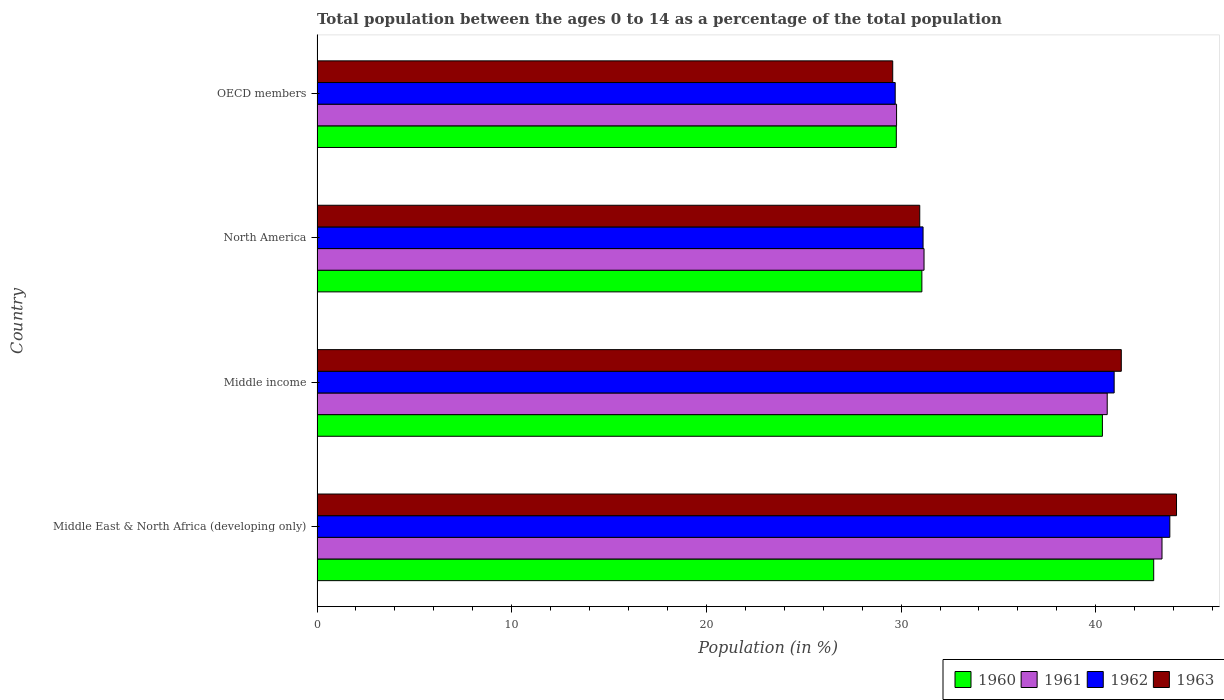How many different coloured bars are there?
Keep it short and to the point. 4. Are the number of bars per tick equal to the number of legend labels?
Ensure brevity in your answer.  Yes. Are the number of bars on each tick of the Y-axis equal?
Keep it short and to the point. Yes. What is the percentage of the population ages 0 to 14 in 1960 in North America?
Keep it short and to the point. 31.07. Across all countries, what is the maximum percentage of the population ages 0 to 14 in 1963?
Your response must be concise. 44.15. Across all countries, what is the minimum percentage of the population ages 0 to 14 in 1962?
Offer a terse response. 29.7. In which country was the percentage of the population ages 0 to 14 in 1960 maximum?
Make the answer very short. Middle East & North Africa (developing only). In which country was the percentage of the population ages 0 to 14 in 1962 minimum?
Provide a short and direct response. OECD members. What is the total percentage of the population ages 0 to 14 in 1962 in the graph?
Provide a short and direct response. 145.57. What is the difference between the percentage of the population ages 0 to 14 in 1960 in Middle income and that in OECD members?
Offer a terse response. 10.59. What is the difference between the percentage of the population ages 0 to 14 in 1960 in Middle income and the percentage of the population ages 0 to 14 in 1961 in Middle East & North Africa (developing only)?
Ensure brevity in your answer.  -3.06. What is the average percentage of the population ages 0 to 14 in 1963 per country?
Keep it short and to the point. 36.5. What is the difference between the percentage of the population ages 0 to 14 in 1961 and percentage of the population ages 0 to 14 in 1960 in OECD members?
Keep it short and to the point. 0.01. What is the ratio of the percentage of the population ages 0 to 14 in 1961 in Middle income to that in OECD members?
Your response must be concise. 1.36. Is the percentage of the population ages 0 to 14 in 1963 in Middle East & North Africa (developing only) less than that in North America?
Provide a short and direct response. No. What is the difference between the highest and the second highest percentage of the population ages 0 to 14 in 1963?
Ensure brevity in your answer.  2.84. What is the difference between the highest and the lowest percentage of the population ages 0 to 14 in 1962?
Provide a short and direct response. 14.11. In how many countries, is the percentage of the population ages 0 to 14 in 1963 greater than the average percentage of the population ages 0 to 14 in 1963 taken over all countries?
Offer a very short reply. 2. Is the sum of the percentage of the population ages 0 to 14 in 1961 in Middle income and North America greater than the maximum percentage of the population ages 0 to 14 in 1960 across all countries?
Keep it short and to the point. Yes. Is it the case that in every country, the sum of the percentage of the population ages 0 to 14 in 1960 and percentage of the population ages 0 to 14 in 1961 is greater than the sum of percentage of the population ages 0 to 14 in 1962 and percentage of the population ages 0 to 14 in 1963?
Provide a short and direct response. No. Is it the case that in every country, the sum of the percentage of the population ages 0 to 14 in 1963 and percentage of the population ages 0 to 14 in 1961 is greater than the percentage of the population ages 0 to 14 in 1962?
Ensure brevity in your answer.  Yes. How many bars are there?
Keep it short and to the point. 16. What is the difference between two consecutive major ticks on the X-axis?
Provide a succinct answer. 10. Does the graph contain any zero values?
Ensure brevity in your answer.  No. Does the graph contain grids?
Ensure brevity in your answer.  No. How are the legend labels stacked?
Offer a very short reply. Horizontal. What is the title of the graph?
Keep it short and to the point. Total population between the ages 0 to 14 as a percentage of the total population. Does "1975" appear as one of the legend labels in the graph?
Make the answer very short. No. What is the label or title of the Y-axis?
Offer a terse response. Country. What is the Population (in %) in 1960 in Middle East & North Africa (developing only)?
Provide a succinct answer. 42.97. What is the Population (in %) in 1961 in Middle East & North Africa (developing only)?
Make the answer very short. 43.4. What is the Population (in %) of 1962 in Middle East & North Africa (developing only)?
Provide a short and direct response. 43.8. What is the Population (in %) in 1963 in Middle East & North Africa (developing only)?
Make the answer very short. 44.15. What is the Population (in %) in 1960 in Middle income?
Keep it short and to the point. 40.34. What is the Population (in %) in 1961 in Middle income?
Keep it short and to the point. 40.59. What is the Population (in %) in 1962 in Middle income?
Your answer should be compact. 40.94. What is the Population (in %) of 1963 in Middle income?
Offer a very short reply. 41.31. What is the Population (in %) of 1960 in North America?
Give a very brief answer. 31.07. What is the Population (in %) of 1961 in North America?
Keep it short and to the point. 31.18. What is the Population (in %) in 1962 in North America?
Provide a succinct answer. 31.13. What is the Population (in %) of 1963 in North America?
Provide a succinct answer. 30.96. What is the Population (in %) in 1960 in OECD members?
Offer a terse response. 29.75. What is the Population (in %) in 1961 in OECD members?
Your response must be concise. 29.77. What is the Population (in %) of 1962 in OECD members?
Ensure brevity in your answer.  29.7. What is the Population (in %) in 1963 in OECD members?
Make the answer very short. 29.57. Across all countries, what is the maximum Population (in %) of 1960?
Offer a very short reply. 42.97. Across all countries, what is the maximum Population (in %) in 1961?
Ensure brevity in your answer.  43.4. Across all countries, what is the maximum Population (in %) of 1962?
Your answer should be compact. 43.8. Across all countries, what is the maximum Population (in %) in 1963?
Make the answer very short. 44.15. Across all countries, what is the minimum Population (in %) in 1960?
Ensure brevity in your answer.  29.75. Across all countries, what is the minimum Population (in %) of 1961?
Keep it short and to the point. 29.77. Across all countries, what is the minimum Population (in %) in 1962?
Give a very brief answer. 29.7. Across all countries, what is the minimum Population (in %) in 1963?
Give a very brief answer. 29.57. What is the total Population (in %) in 1960 in the graph?
Offer a very short reply. 144.14. What is the total Population (in %) of 1961 in the graph?
Provide a succinct answer. 144.93. What is the total Population (in %) of 1962 in the graph?
Offer a very short reply. 145.57. What is the total Population (in %) in 1963 in the graph?
Provide a short and direct response. 145.98. What is the difference between the Population (in %) of 1960 in Middle East & North Africa (developing only) and that in Middle income?
Your answer should be very brief. 2.63. What is the difference between the Population (in %) in 1961 in Middle East & North Africa (developing only) and that in Middle income?
Your response must be concise. 2.81. What is the difference between the Population (in %) of 1962 in Middle East & North Africa (developing only) and that in Middle income?
Offer a very short reply. 2.86. What is the difference between the Population (in %) in 1963 in Middle East & North Africa (developing only) and that in Middle income?
Your answer should be very brief. 2.84. What is the difference between the Population (in %) of 1960 in Middle East & North Africa (developing only) and that in North America?
Your answer should be very brief. 11.91. What is the difference between the Population (in %) of 1961 in Middle East & North Africa (developing only) and that in North America?
Provide a succinct answer. 12.22. What is the difference between the Population (in %) of 1962 in Middle East & North Africa (developing only) and that in North America?
Ensure brevity in your answer.  12.67. What is the difference between the Population (in %) of 1963 in Middle East & North Africa (developing only) and that in North America?
Offer a terse response. 13.19. What is the difference between the Population (in %) of 1960 in Middle East & North Africa (developing only) and that in OECD members?
Offer a terse response. 13.22. What is the difference between the Population (in %) of 1961 in Middle East & North Africa (developing only) and that in OECD members?
Keep it short and to the point. 13.63. What is the difference between the Population (in %) of 1962 in Middle East & North Africa (developing only) and that in OECD members?
Provide a short and direct response. 14.11. What is the difference between the Population (in %) of 1963 in Middle East & North Africa (developing only) and that in OECD members?
Your response must be concise. 14.58. What is the difference between the Population (in %) in 1960 in Middle income and that in North America?
Provide a succinct answer. 9.27. What is the difference between the Population (in %) of 1961 in Middle income and that in North America?
Provide a succinct answer. 9.41. What is the difference between the Population (in %) in 1962 in Middle income and that in North America?
Make the answer very short. 9.82. What is the difference between the Population (in %) in 1963 in Middle income and that in North America?
Make the answer very short. 10.35. What is the difference between the Population (in %) of 1960 in Middle income and that in OECD members?
Offer a terse response. 10.59. What is the difference between the Population (in %) of 1961 in Middle income and that in OECD members?
Make the answer very short. 10.82. What is the difference between the Population (in %) of 1962 in Middle income and that in OECD members?
Offer a terse response. 11.25. What is the difference between the Population (in %) in 1963 in Middle income and that in OECD members?
Your answer should be compact. 11.74. What is the difference between the Population (in %) in 1960 in North America and that in OECD members?
Offer a terse response. 1.31. What is the difference between the Population (in %) of 1961 in North America and that in OECD members?
Your answer should be very brief. 1.41. What is the difference between the Population (in %) in 1962 in North America and that in OECD members?
Keep it short and to the point. 1.43. What is the difference between the Population (in %) of 1963 in North America and that in OECD members?
Offer a terse response. 1.39. What is the difference between the Population (in %) in 1960 in Middle East & North Africa (developing only) and the Population (in %) in 1961 in Middle income?
Provide a short and direct response. 2.39. What is the difference between the Population (in %) of 1960 in Middle East & North Africa (developing only) and the Population (in %) of 1962 in Middle income?
Keep it short and to the point. 2.03. What is the difference between the Population (in %) in 1960 in Middle East & North Africa (developing only) and the Population (in %) in 1963 in Middle income?
Offer a terse response. 1.66. What is the difference between the Population (in %) of 1961 in Middle East & North Africa (developing only) and the Population (in %) of 1962 in Middle income?
Your answer should be compact. 2.46. What is the difference between the Population (in %) of 1961 in Middle East & North Africa (developing only) and the Population (in %) of 1963 in Middle income?
Your answer should be very brief. 2.09. What is the difference between the Population (in %) in 1962 in Middle East & North Africa (developing only) and the Population (in %) in 1963 in Middle income?
Offer a terse response. 2.49. What is the difference between the Population (in %) of 1960 in Middle East & North Africa (developing only) and the Population (in %) of 1961 in North America?
Make the answer very short. 11.8. What is the difference between the Population (in %) of 1960 in Middle East & North Africa (developing only) and the Population (in %) of 1962 in North America?
Provide a short and direct response. 11.85. What is the difference between the Population (in %) of 1960 in Middle East & North Africa (developing only) and the Population (in %) of 1963 in North America?
Provide a short and direct response. 12.02. What is the difference between the Population (in %) of 1961 in Middle East & North Africa (developing only) and the Population (in %) of 1962 in North America?
Your answer should be compact. 12.27. What is the difference between the Population (in %) in 1961 in Middle East & North Africa (developing only) and the Population (in %) in 1963 in North America?
Keep it short and to the point. 12.44. What is the difference between the Population (in %) of 1962 in Middle East & North Africa (developing only) and the Population (in %) of 1963 in North America?
Offer a very short reply. 12.85. What is the difference between the Population (in %) in 1960 in Middle East & North Africa (developing only) and the Population (in %) in 1961 in OECD members?
Your answer should be compact. 13.21. What is the difference between the Population (in %) in 1960 in Middle East & North Africa (developing only) and the Population (in %) in 1962 in OECD members?
Offer a terse response. 13.28. What is the difference between the Population (in %) of 1960 in Middle East & North Africa (developing only) and the Population (in %) of 1963 in OECD members?
Your answer should be compact. 13.41. What is the difference between the Population (in %) in 1961 in Middle East & North Africa (developing only) and the Population (in %) in 1962 in OECD members?
Your response must be concise. 13.7. What is the difference between the Population (in %) in 1961 in Middle East & North Africa (developing only) and the Population (in %) in 1963 in OECD members?
Your answer should be very brief. 13.83. What is the difference between the Population (in %) in 1962 in Middle East & North Africa (developing only) and the Population (in %) in 1963 in OECD members?
Keep it short and to the point. 14.23. What is the difference between the Population (in %) in 1960 in Middle income and the Population (in %) in 1961 in North America?
Offer a terse response. 9.16. What is the difference between the Population (in %) in 1960 in Middle income and the Population (in %) in 1962 in North America?
Offer a terse response. 9.21. What is the difference between the Population (in %) of 1960 in Middle income and the Population (in %) of 1963 in North America?
Ensure brevity in your answer.  9.38. What is the difference between the Population (in %) of 1961 in Middle income and the Population (in %) of 1962 in North America?
Your answer should be compact. 9.46. What is the difference between the Population (in %) of 1961 in Middle income and the Population (in %) of 1963 in North America?
Your answer should be very brief. 9.63. What is the difference between the Population (in %) in 1962 in Middle income and the Population (in %) in 1963 in North America?
Offer a very short reply. 9.99. What is the difference between the Population (in %) of 1960 in Middle income and the Population (in %) of 1961 in OECD members?
Your answer should be compact. 10.57. What is the difference between the Population (in %) of 1960 in Middle income and the Population (in %) of 1962 in OECD members?
Offer a very short reply. 10.64. What is the difference between the Population (in %) of 1960 in Middle income and the Population (in %) of 1963 in OECD members?
Ensure brevity in your answer.  10.77. What is the difference between the Population (in %) of 1961 in Middle income and the Population (in %) of 1962 in OECD members?
Your answer should be compact. 10.89. What is the difference between the Population (in %) in 1961 in Middle income and the Population (in %) in 1963 in OECD members?
Your answer should be very brief. 11.02. What is the difference between the Population (in %) of 1962 in Middle income and the Population (in %) of 1963 in OECD members?
Keep it short and to the point. 11.37. What is the difference between the Population (in %) in 1960 in North America and the Population (in %) in 1961 in OECD members?
Offer a very short reply. 1.3. What is the difference between the Population (in %) in 1960 in North America and the Population (in %) in 1962 in OECD members?
Provide a succinct answer. 1.37. What is the difference between the Population (in %) in 1960 in North America and the Population (in %) in 1963 in OECD members?
Make the answer very short. 1.5. What is the difference between the Population (in %) in 1961 in North America and the Population (in %) in 1962 in OECD members?
Offer a very short reply. 1.48. What is the difference between the Population (in %) of 1961 in North America and the Population (in %) of 1963 in OECD members?
Ensure brevity in your answer.  1.61. What is the difference between the Population (in %) in 1962 in North America and the Population (in %) in 1963 in OECD members?
Make the answer very short. 1.56. What is the average Population (in %) of 1960 per country?
Provide a succinct answer. 36.03. What is the average Population (in %) in 1961 per country?
Make the answer very short. 36.23. What is the average Population (in %) in 1962 per country?
Offer a terse response. 36.39. What is the average Population (in %) of 1963 per country?
Offer a terse response. 36.5. What is the difference between the Population (in %) of 1960 and Population (in %) of 1961 in Middle East & North Africa (developing only)?
Make the answer very short. -0.43. What is the difference between the Population (in %) of 1960 and Population (in %) of 1962 in Middle East & North Africa (developing only)?
Your response must be concise. -0.83. What is the difference between the Population (in %) of 1960 and Population (in %) of 1963 in Middle East & North Africa (developing only)?
Ensure brevity in your answer.  -1.17. What is the difference between the Population (in %) of 1961 and Population (in %) of 1962 in Middle East & North Africa (developing only)?
Offer a very short reply. -0.4. What is the difference between the Population (in %) of 1961 and Population (in %) of 1963 in Middle East & North Africa (developing only)?
Ensure brevity in your answer.  -0.75. What is the difference between the Population (in %) in 1962 and Population (in %) in 1963 in Middle East & North Africa (developing only)?
Give a very brief answer. -0.34. What is the difference between the Population (in %) in 1960 and Population (in %) in 1961 in Middle income?
Offer a very short reply. -0.25. What is the difference between the Population (in %) of 1960 and Population (in %) of 1962 in Middle income?
Provide a short and direct response. -0.6. What is the difference between the Population (in %) of 1960 and Population (in %) of 1963 in Middle income?
Your answer should be compact. -0.97. What is the difference between the Population (in %) of 1961 and Population (in %) of 1962 in Middle income?
Ensure brevity in your answer.  -0.36. What is the difference between the Population (in %) of 1961 and Population (in %) of 1963 in Middle income?
Make the answer very short. -0.72. What is the difference between the Population (in %) in 1962 and Population (in %) in 1963 in Middle income?
Your answer should be very brief. -0.37. What is the difference between the Population (in %) in 1960 and Population (in %) in 1961 in North America?
Your answer should be compact. -0.11. What is the difference between the Population (in %) of 1960 and Population (in %) of 1962 in North America?
Keep it short and to the point. -0.06. What is the difference between the Population (in %) in 1960 and Population (in %) in 1963 in North America?
Provide a short and direct response. 0.11. What is the difference between the Population (in %) in 1961 and Population (in %) in 1962 in North America?
Give a very brief answer. 0.05. What is the difference between the Population (in %) of 1961 and Population (in %) of 1963 in North America?
Give a very brief answer. 0.22. What is the difference between the Population (in %) in 1962 and Population (in %) in 1963 in North America?
Give a very brief answer. 0.17. What is the difference between the Population (in %) in 1960 and Population (in %) in 1961 in OECD members?
Keep it short and to the point. -0.01. What is the difference between the Population (in %) in 1960 and Population (in %) in 1962 in OECD members?
Give a very brief answer. 0.06. What is the difference between the Population (in %) of 1960 and Population (in %) of 1963 in OECD members?
Provide a succinct answer. 0.18. What is the difference between the Population (in %) of 1961 and Population (in %) of 1962 in OECD members?
Provide a short and direct response. 0.07. What is the difference between the Population (in %) in 1961 and Population (in %) in 1963 in OECD members?
Offer a terse response. 0.2. What is the difference between the Population (in %) of 1962 and Population (in %) of 1963 in OECD members?
Give a very brief answer. 0.13. What is the ratio of the Population (in %) in 1960 in Middle East & North Africa (developing only) to that in Middle income?
Make the answer very short. 1.07. What is the ratio of the Population (in %) in 1961 in Middle East & North Africa (developing only) to that in Middle income?
Offer a terse response. 1.07. What is the ratio of the Population (in %) in 1962 in Middle East & North Africa (developing only) to that in Middle income?
Offer a very short reply. 1.07. What is the ratio of the Population (in %) of 1963 in Middle East & North Africa (developing only) to that in Middle income?
Provide a short and direct response. 1.07. What is the ratio of the Population (in %) of 1960 in Middle East & North Africa (developing only) to that in North America?
Offer a very short reply. 1.38. What is the ratio of the Population (in %) in 1961 in Middle East & North Africa (developing only) to that in North America?
Ensure brevity in your answer.  1.39. What is the ratio of the Population (in %) in 1962 in Middle East & North Africa (developing only) to that in North America?
Your answer should be compact. 1.41. What is the ratio of the Population (in %) of 1963 in Middle East & North Africa (developing only) to that in North America?
Give a very brief answer. 1.43. What is the ratio of the Population (in %) of 1960 in Middle East & North Africa (developing only) to that in OECD members?
Offer a very short reply. 1.44. What is the ratio of the Population (in %) in 1961 in Middle East & North Africa (developing only) to that in OECD members?
Provide a short and direct response. 1.46. What is the ratio of the Population (in %) of 1962 in Middle East & North Africa (developing only) to that in OECD members?
Your answer should be compact. 1.48. What is the ratio of the Population (in %) of 1963 in Middle East & North Africa (developing only) to that in OECD members?
Make the answer very short. 1.49. What is the ratio of the Population (in %) of 1960 in Middle income to that in North America?
Make the answer very short. 1.3. What is the ratio of the Population (in %) in 1961 in Middle income to that in North America?
Make the answer very short. 1.3. What is the ratio of the Population (in %) of 1962 in Middle income to that in North America?
Offer a very short reply. 1.32. What is the ratio of the Population (in %) in 1963 in Middle income to that in North America?
Your answer should be very brief. 1.33. What is the ratio of the Population (in %) in 1960 in Middle income to that in OECD members?
Offer a terse response. 1.36. What is the ratio of the Population (in %) of 1961 in Middle income to that in OECD members?
Offer a very short reply. 1.36. What is the ratio of the Population (in %) of 1962 in Middle income to that in OECD members?
Your response must be concise. 1.38. What is the ratio of the Population (in %) in 1963 in Middle income to that in OECD members?
Ensure brevity in your answer.  1.4. What is the ratio of the Population (in %) in 1960 in North America to that in OECD members?
Make the answer very short. 1.04. What is the ratio of the Population (in %) in 1961 in North America to that in OECD members?
Provide a short and direct response. 1.05. What is the ratio of the Population (in %) of 1962 in North America to that in OECD members?
Provide a short and direct response. 1.05. What is the ratio of the Population (in %) in 1963 in North America to that in OECD members?
Your answer should be very brief. 1.05. What is the difference between the highest and the second highest Population (in %) of 1960?
Provide a short and direct response. 2.63. What is the difference between the highest and the second highest Population (in %) in 1961?
Give a very brief answer. 2.81. What is the difference between the highest and the second highest Population (in %) in 1962?
Give a very brief answer. 2.86. What is the difference between the highest and the second highest Population (in %) in 1963?
Give a very brief answer. 2.84. What is the difference between the highest and the lowest Population (in %) of 1960?
Provide a short and direct response. 13.22. What is the difference between the highest and the lowest Population (in %) in 1961?
Provide a short and direct response. 13.63. What is the difference between the highest and the lowest Population (in %) in 1962?
Offer a terse response. 14.11. What is the difference between the highest and the lowest Population (in %) of 1963?
Offer a very short reply. 14.58. 